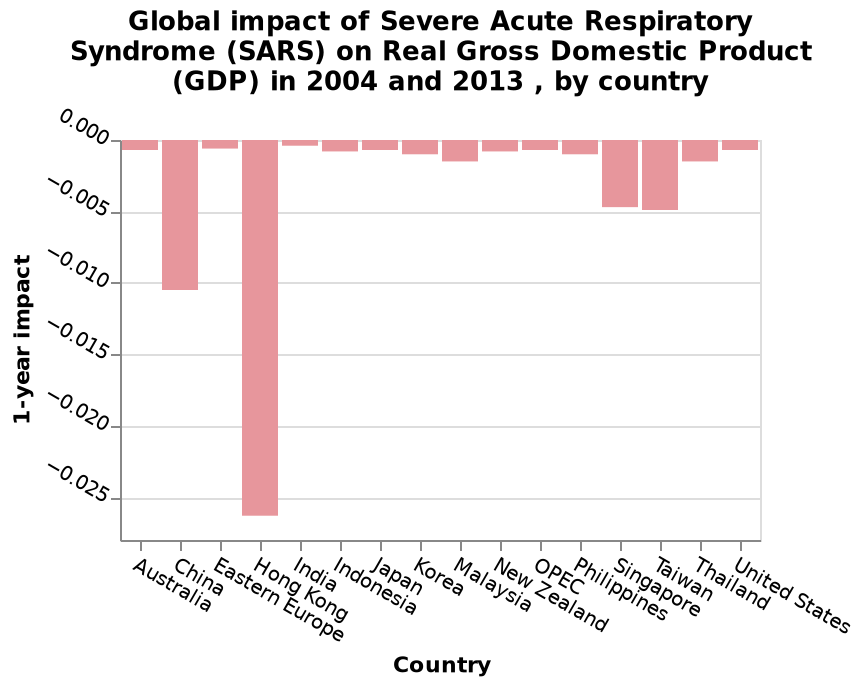<image>
What does the chart depict about the impact of South East Asian countries on GDP?  The chart shows that South East Asian countries have the largest impact on GDP. What is the scope of the data analyzed in the bar plot? The data analyzed in the bar plot represents the global impact of SARS on Real GDP in 2004 and 2013 for different countries. How is the impact on GDP measured in the bar plot? The impact on GDP is measured on the y-axis of the bar plot using a 1-year scale. 